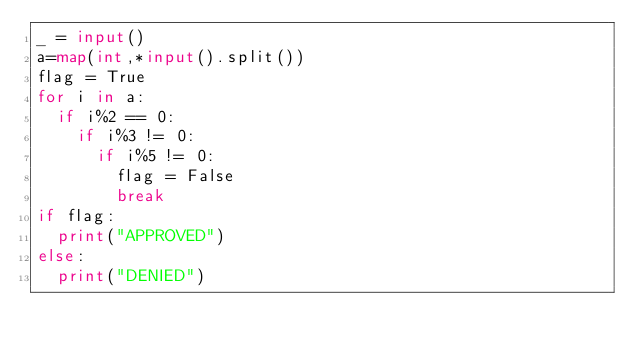<code> <loc_0><loc_0><loc_500><loc_500><_Python_>_ = input()
a=map(int,*input().split())
flag = True
for i in a:
  if i%2 == 0:
    if i%3 != 0:
      if i%5 != 0:
        flag = False
        break
if flag:
  print("APPROVED")
else:
  print("DENIED")</code> 